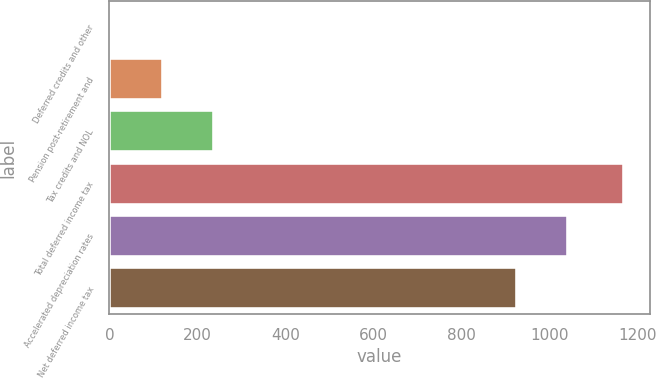Convert chart. <chart><loc_0><loc_0><loc_500><loc_500><bar_chart><fcel>Deferred credits and other<fcel>Pension post-retirement and<fcel>Tax credits and NOL<fcel>Total deferred income tax<fcel>Accelerated depreciation rates<fcel>Net deferred income tax<nl><fcel>6<fcel>122.2<fcel>238.4<fcel>1168<fcel>1041.2<fcel>925<nl></chart> 